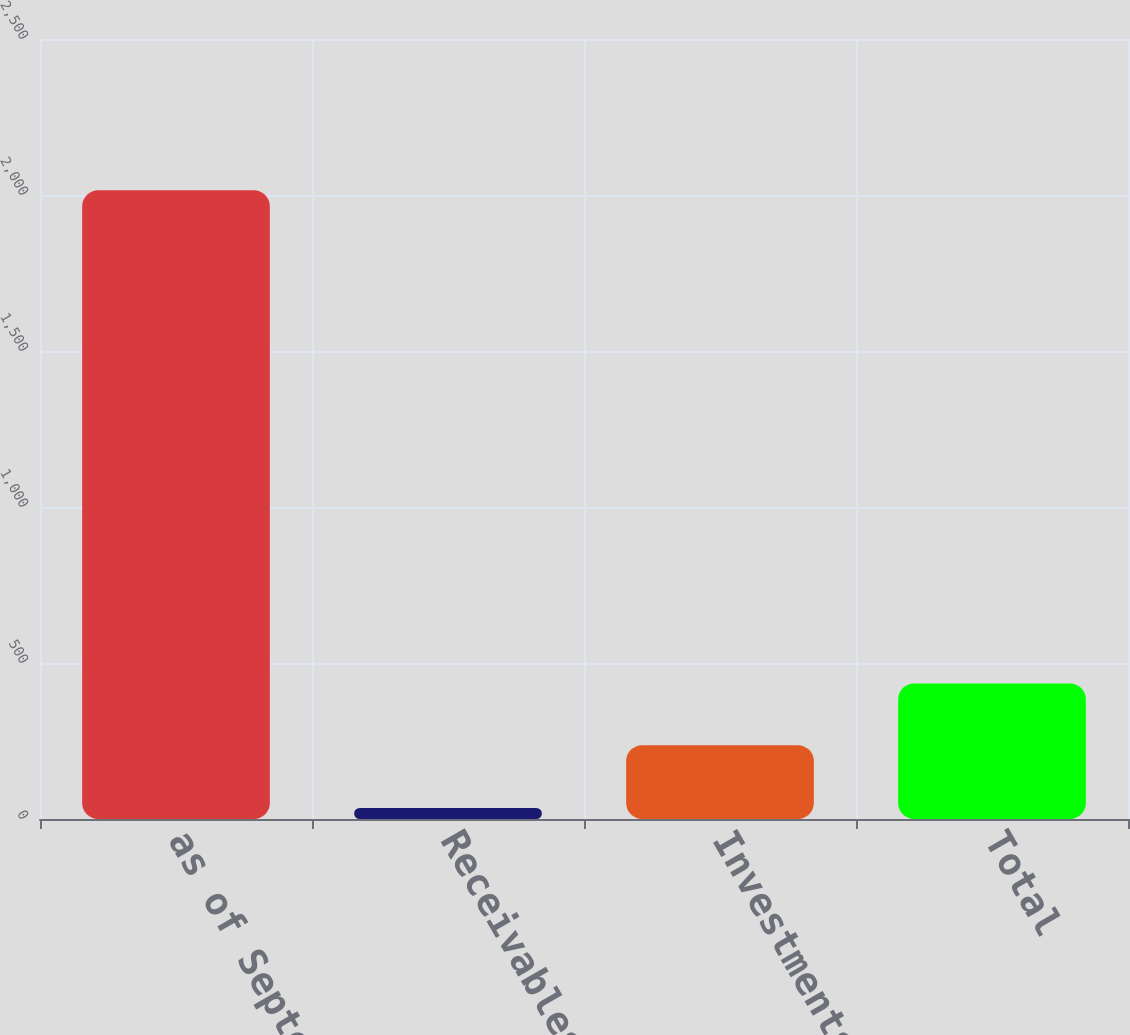<chart> <loc_0><loc_0><loc_500><loc_500><bar_chart><fcel>as of September 30<fcel>Receivables<fcel>Investments<fcel>Total<nl><fcel>2015<fcel>35.5<fcel>236.6<fcel>434.55<nl></chart> 